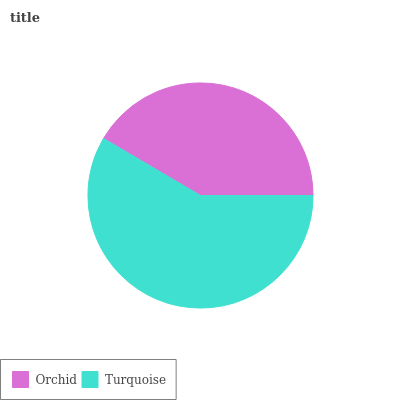Is Orchid the minimum?
Answer yes or no. Yes. Is Turquoise the maximum?
Answer yes or no. Yes. Is Turquoise the minimum?
Answer yes or no. No. Is Turquoise greater than Orchid?
Answer yes or no. Yes. Is Orchid less than Turquoise?
Answer yes or no. Yes. Is Orchid greater than Turquoise?
Answer yes or no. No. Is Turquoise less than Orchid?
Answer yes or no. No. Is Turquoise the high median?
Answer yes or no. Yes. Is Orchid the low median?
Answer yes or no. Yes. Is Orchid the high median?
Answer yes or no. No. Is Turquoise the low median?
Answer yes or no. No. 